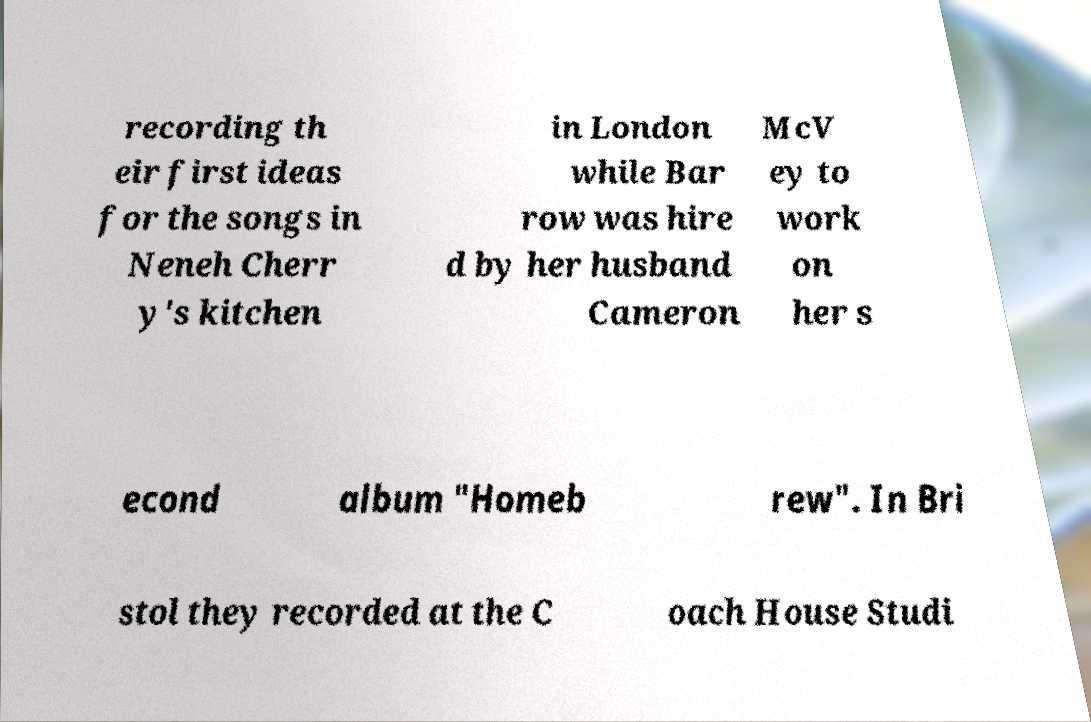Please read and relay the text visible in this image. What does it say? recording th eir first ideas for the songs in Neneh Cherr y's kitchen in London while Bar row was hire d by her husband Cameron McV ey to work on her s econd album "Homeb rew". In Bri stol they recorded at the C oach House Studi 